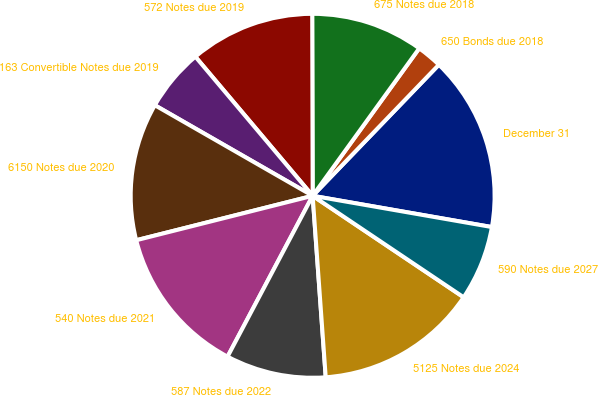Convert chart. <chart><loc_0><loc_0><loc_500><loc_500><pie_chart><fcel>December 31<fcel>650 Bonds due 2018<fcel>675 Notes due 2018<fcel>572 Notes due 2019<fcel>163 Convertible Notes due 2019<fcel>6150 Notes due 2020<fcel>540 Notes due 2021<fcel>587 Notes due 2022<fcel>5125 Notes due 2024<fcel>590 Notes due 2027<nl><fcel>15.55%<fcel>2.24%<fcel>10.0%<fcel>11.11%<fcel>5.56%<fcel>12.22%<fcel>13.33%<fcel>8.89%<fcel>14.44%<fcel>6.67%<nl></chart> 